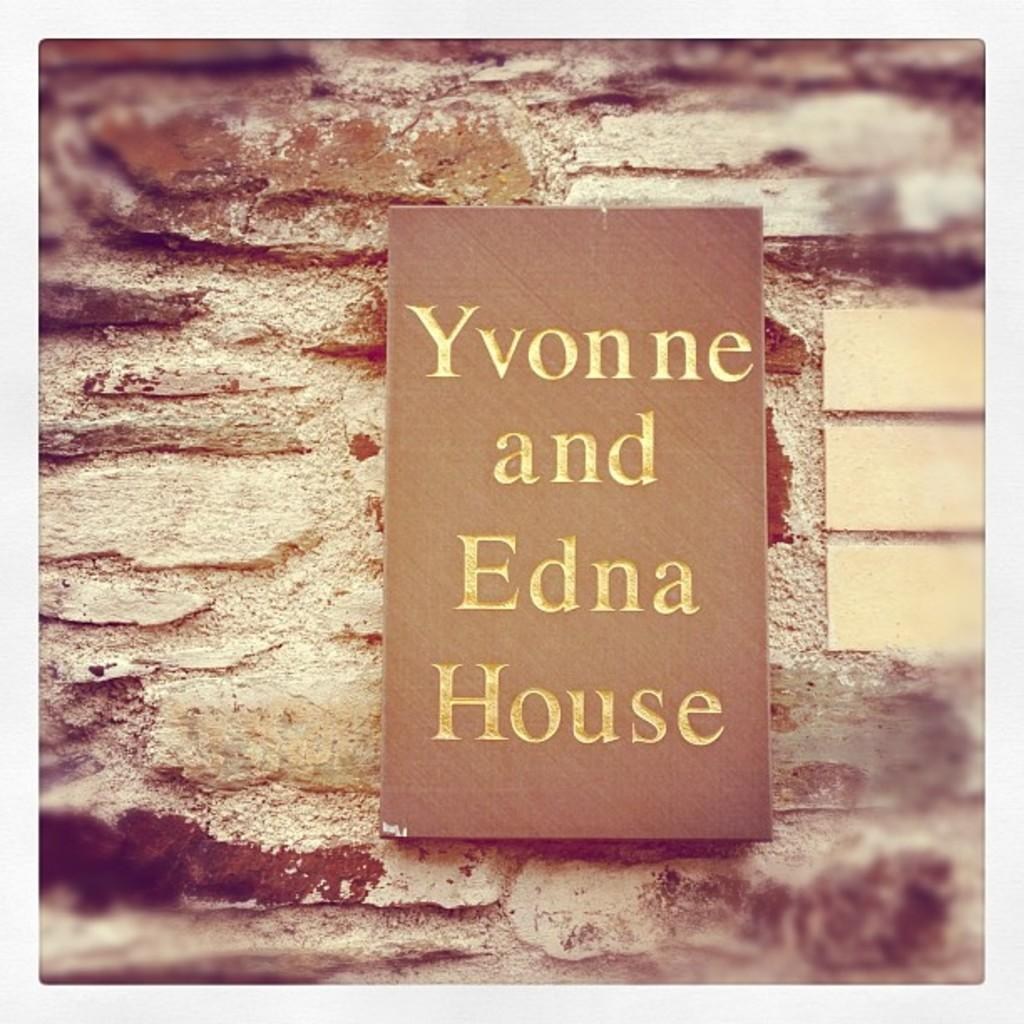<image>
Provide a brief description of the given image. A wood block sitting on some bricks that says Yvonne and Edna House. 